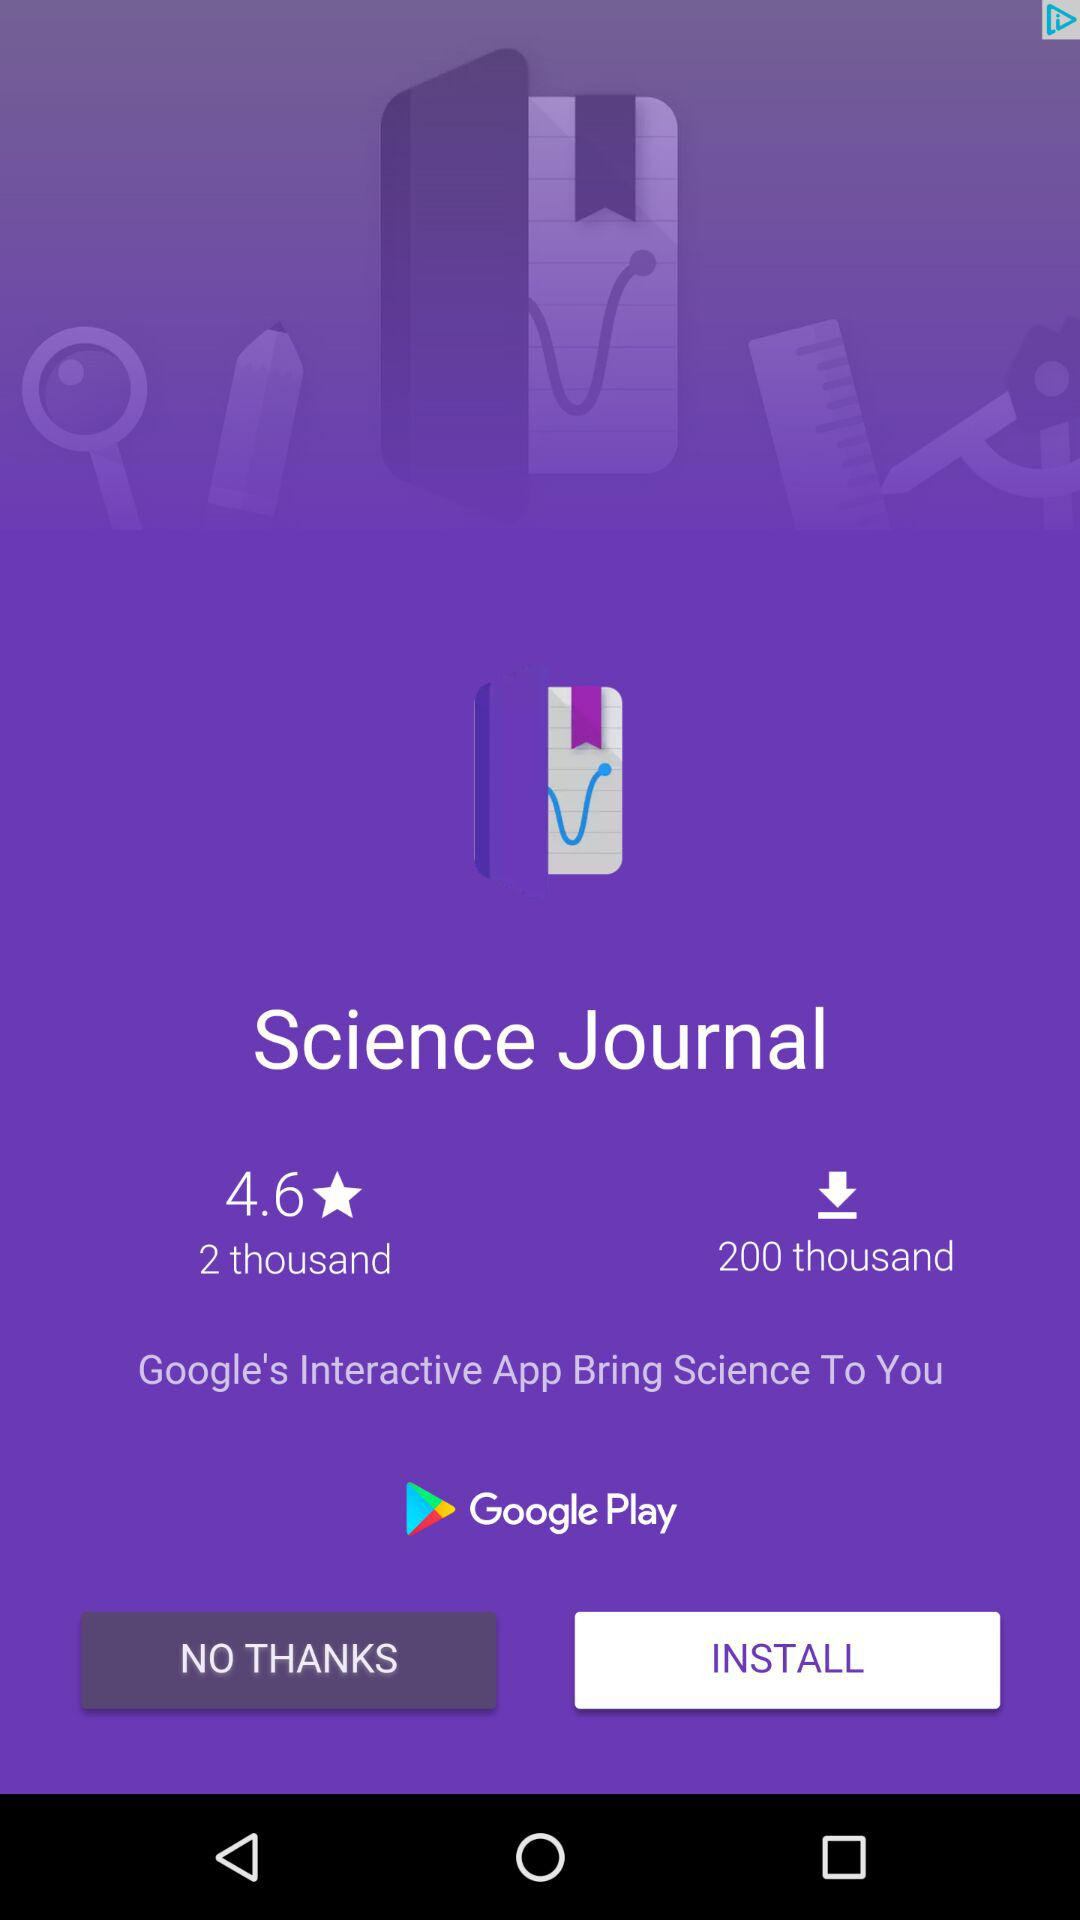How many more downloads does the app have than reviews?
Answer the question using a single word or phrase. 198000 